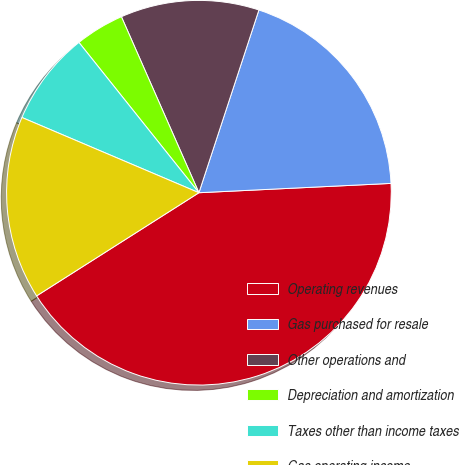Convert chart to OTSL. <chart><loc_0><loc_0><loc_500><loc_500><pie_chart><fcel>Operating revenues<fcel>Gas purchased for resale<fcel>Other operations and<fcel>Depreciation and amortization<fcel>Taxes other than income taxes<fcel>Gas operating income<nl><fcel>41.76%<fcel>19.18%<fcel>11.65%<fcel>4.12%<fcel>7.88%<fcel>15.41%<nl></chart> 